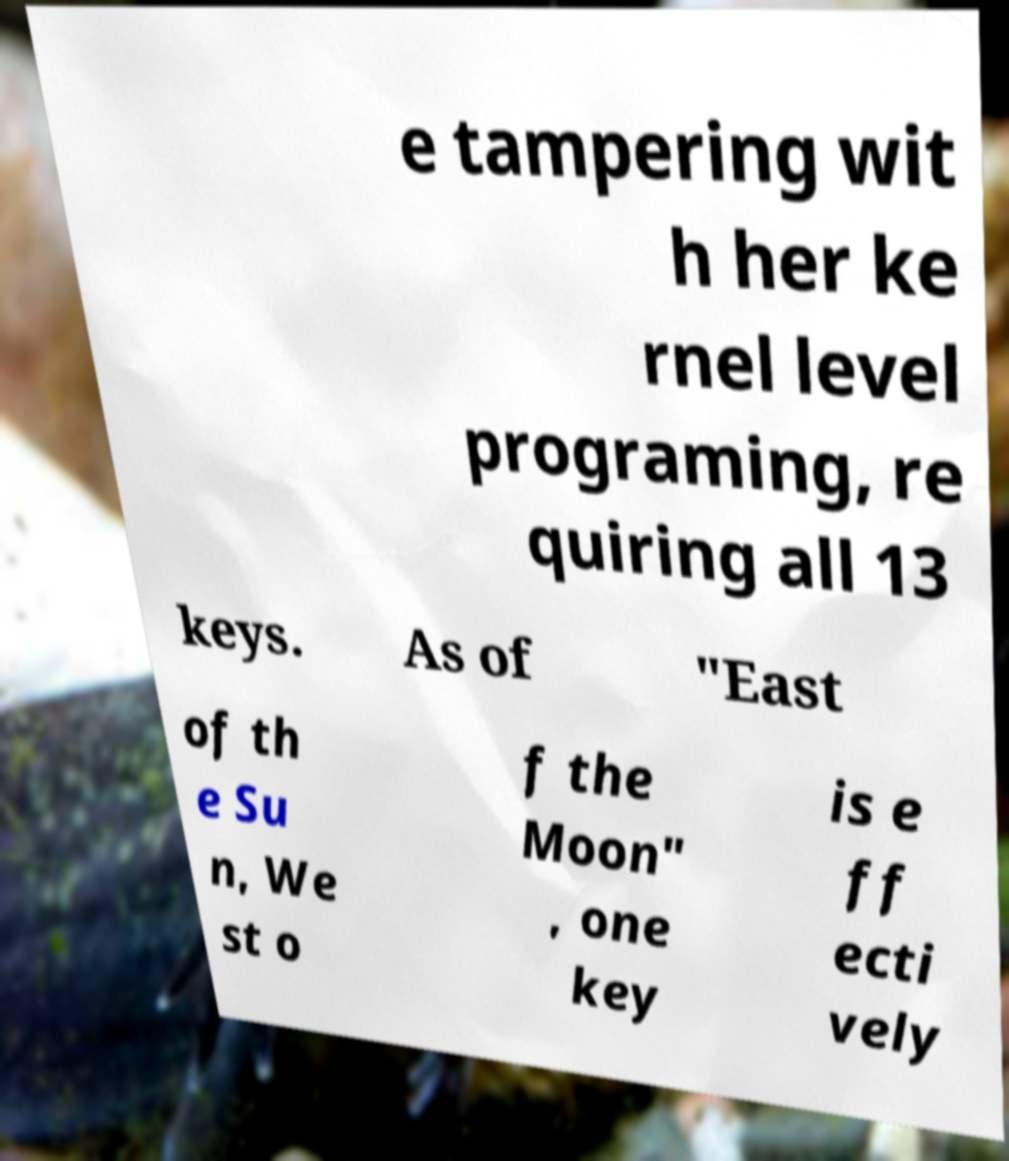Could you extract and type out the text from this image? e tampering wit h her ke rnel level programing, re quiring all 13 keys. As of "East of th e Su n, We st o f the Moon" , one key is e ff ecti vely 